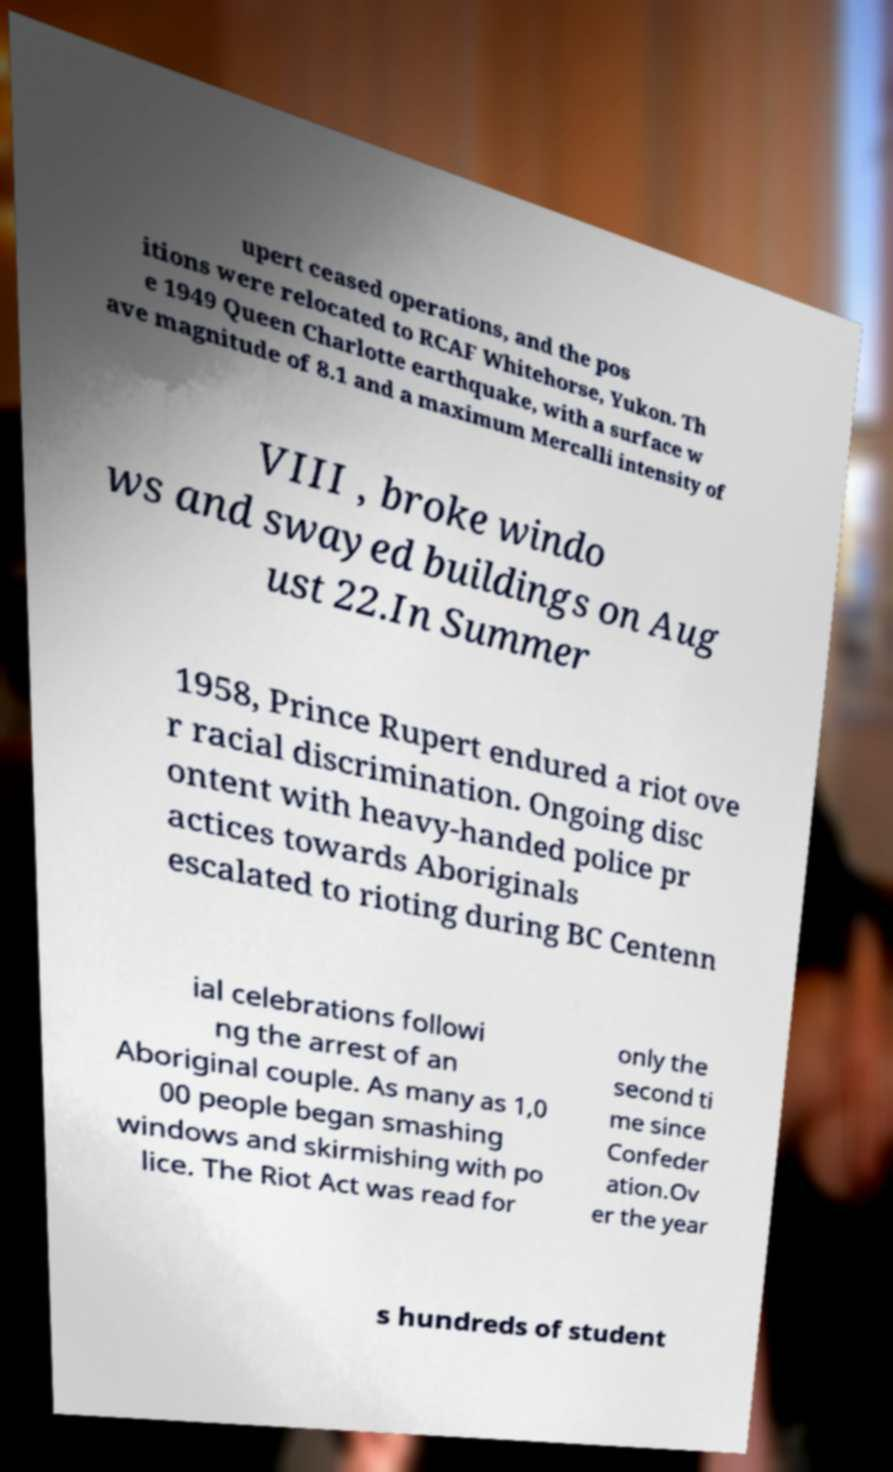There's text embedded in this image that I need extracted. Can you transcribe it verbatim? upert ceased operations, and the pos itions were relocated to RCAF Whitehorse, Yukon. Th e 1949 Queen Charlotte earthquake, with a surface w ave magnitude of 8.1 and a maximum Mercalli intensity of VIII , broke windo ws and swayed buildings on Aug ust 22.In Summer 1958, Prince Rupert endured a riot ove r racial discrimination. Ongoing disc ontent with heavy-handed police pr actices towards Aboriginals escalated to rioting during BC Centenn ial celebrations followi ng the arrest of an Aboriginal couple. As many as 1,0 00 people began smashing windows and skirmishing with po lice. The Riot Act was read for only the second ti me since Confeder ation.Ov er the year s hundreds of student 